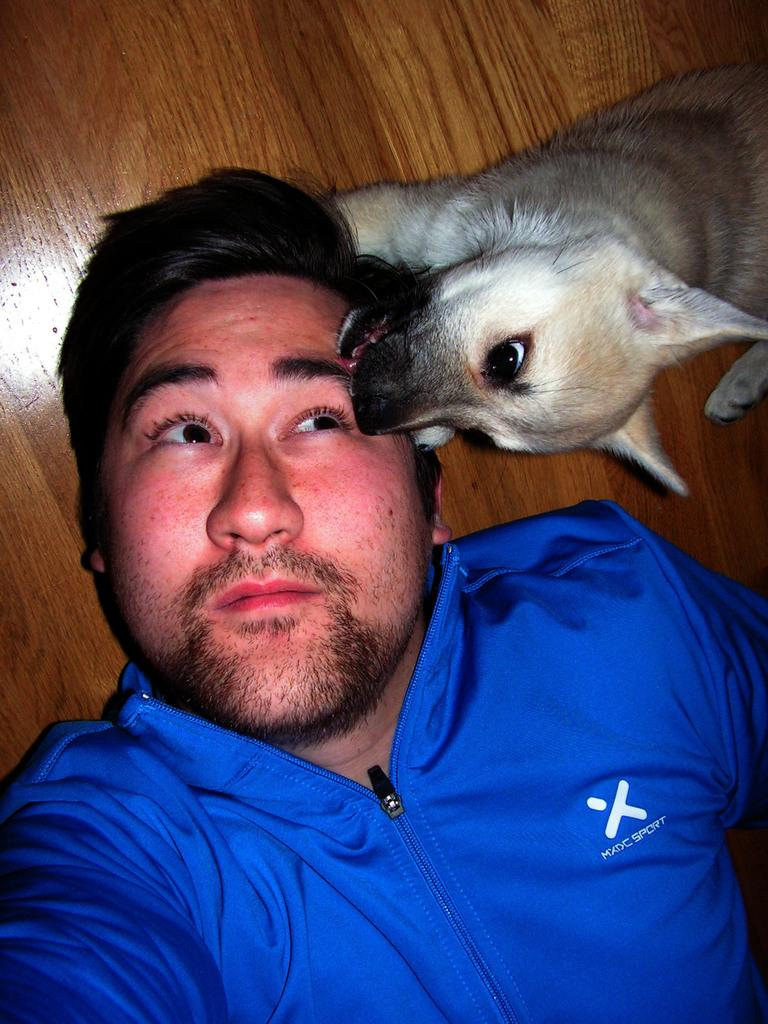Who is present in the image? There is a man in the image. What is the man wearing? The man is wearing a blue shirt. What is the man's position in the image? The man is laying on the floor. What other living creature is in the image? There is a dog in the image. What type of flooring is visible in the background? The background appears to be a wooden floor. How many bikes are being taxed in the image? There are no bikes or tax-related information present in the image. What is the connection between the man and the dog in the image? The provided facts do not mention any connection between the man and the dog; they are simply both present in the image. 